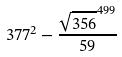<formula> <loc_0><loc_0><loc_500><loc_500>3 7 7 ^ { 2 } - \frac { \sqrt { 3 5 6 } ^ { 4 9 9 } } { 5 9 }</formula> 